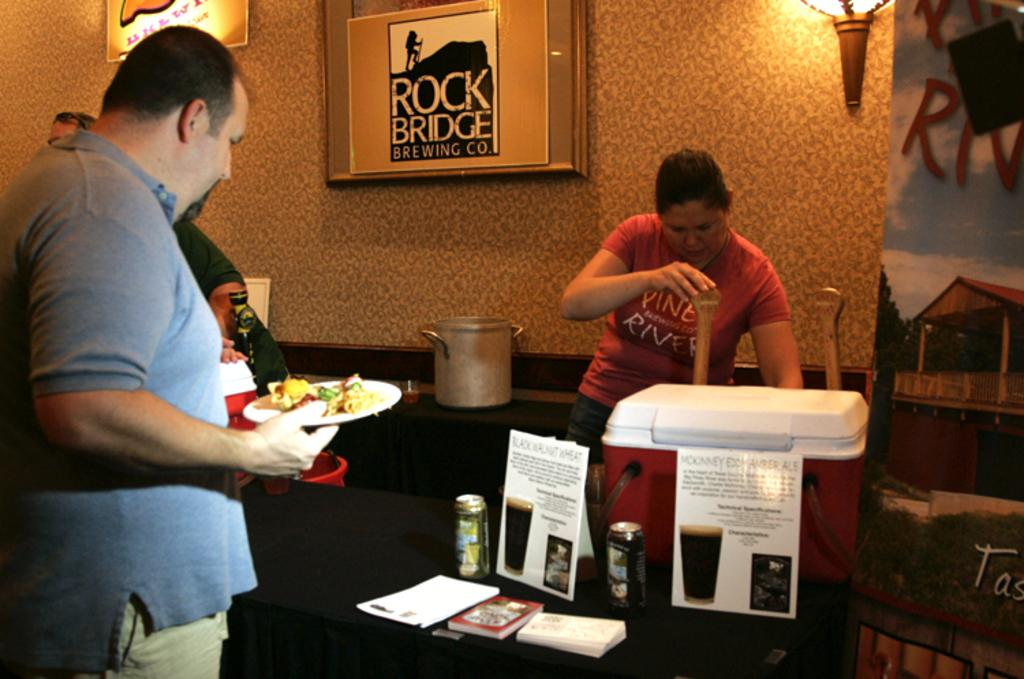Provide a one-sentence caption for the provided image. A man with a plate of food stands in front of a framed sign for Rock Bridge Brewing company. 